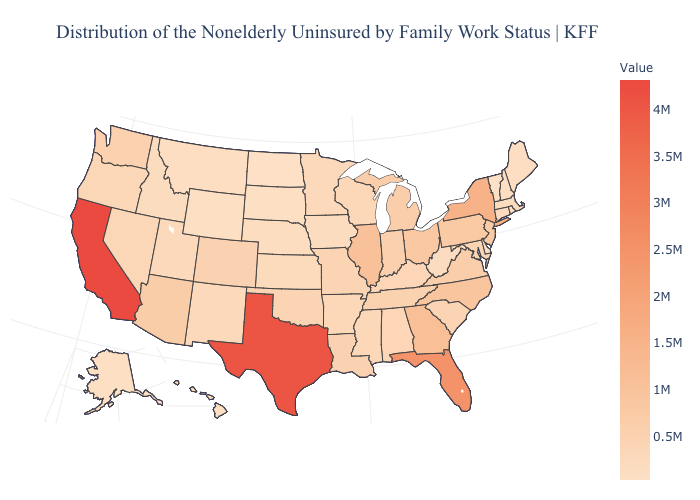Does North Dakota have the lowest value in the MidWest?
Give a very brief answer. Yes. Does Tennessee have a lower value than Vermont?
Write a very short answer. No. Does New York have the highest value in the Northeast?
Quick response, please. Yes. Among the states that border Vermont , does New Hampshire have the lowest value?
Keep it brief. Yes. 